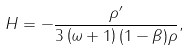<formula> <loc_0><loc_0><loc_500><loc_500>H = - \frac { \rho ^ { \prime } } { 3 \left ( \omega + 1 \right ) ( 1 - \beta ) \rho } ,</formula> 